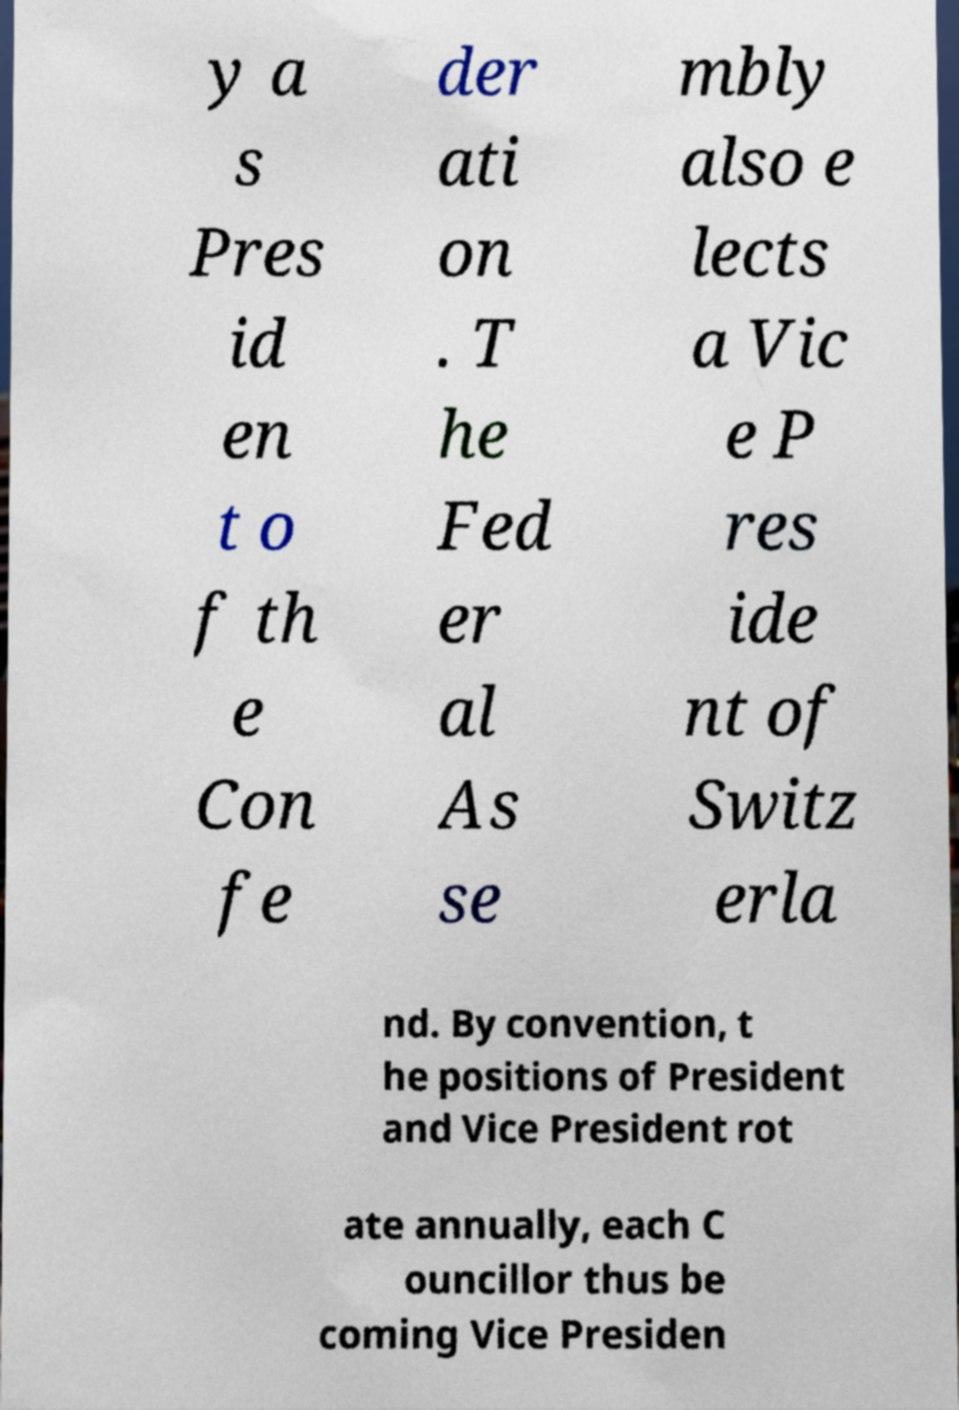Can you read and provide the text displayed in the image?This photo seems to have some interesting text. Can you extract and type it out for me? y a s Pres id en t o f th e Con fe der ati on . T he Fed er al As se mbly also e lects a Vic e P res ide nt of Switz erla nd. By convention, t he positions of President and Vice President rot ate annually, each C ouncillor thus be coming Vice Presiden 